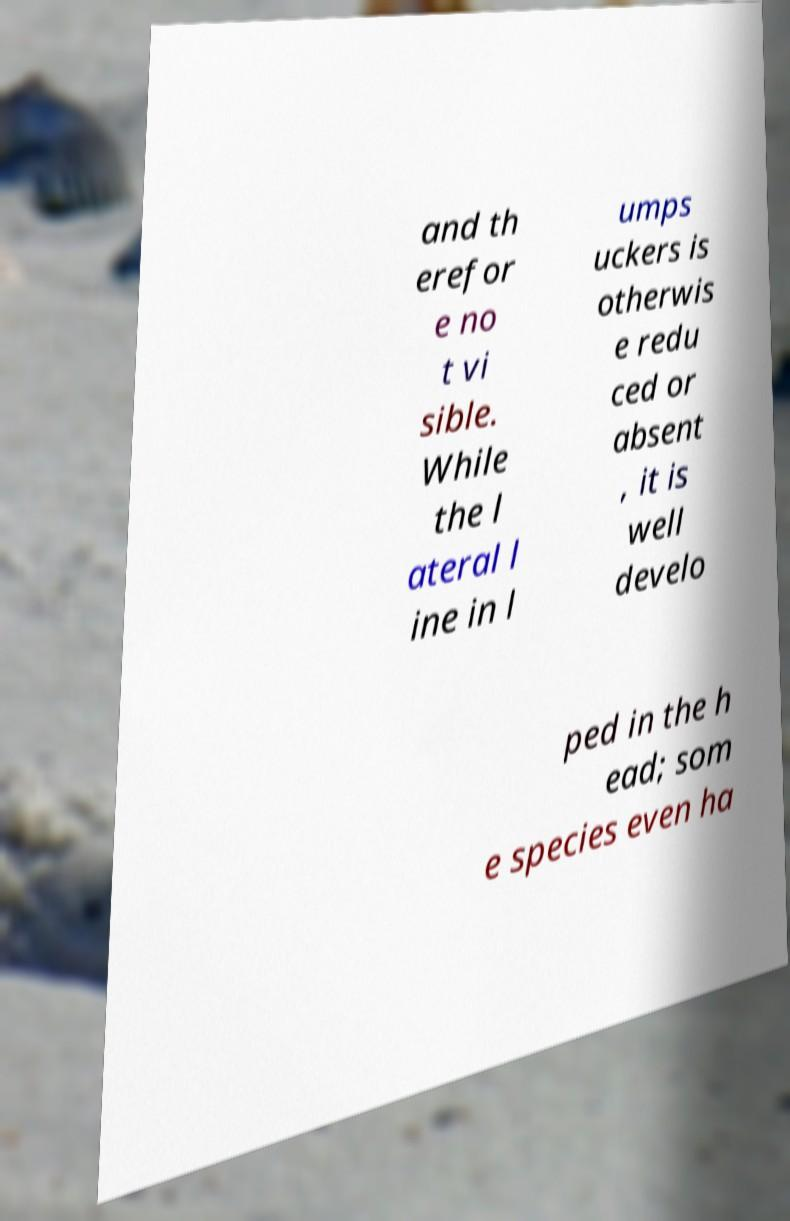I need the written content from this picture converted into text. Can you do that? and th erefor e no t vi sible. While the l ateral l ine in l umps uckers is otherwis e redu ced or absent , it is well develo ped in the h ead; som e species even ha 